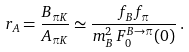Convert formula to latex. <formula><loc_0><loc_0><loc_500><loc_500>r _ { A } = \frac { B _ { \pi K } } { A _ { \pi K } } \simeq \frac { f _ { B } f _ { \pi } } { m _ { B } ^ { 2 } \, F _ { 0 } ^ { B \to \pi } ( 0 ) } \, .</formula> 